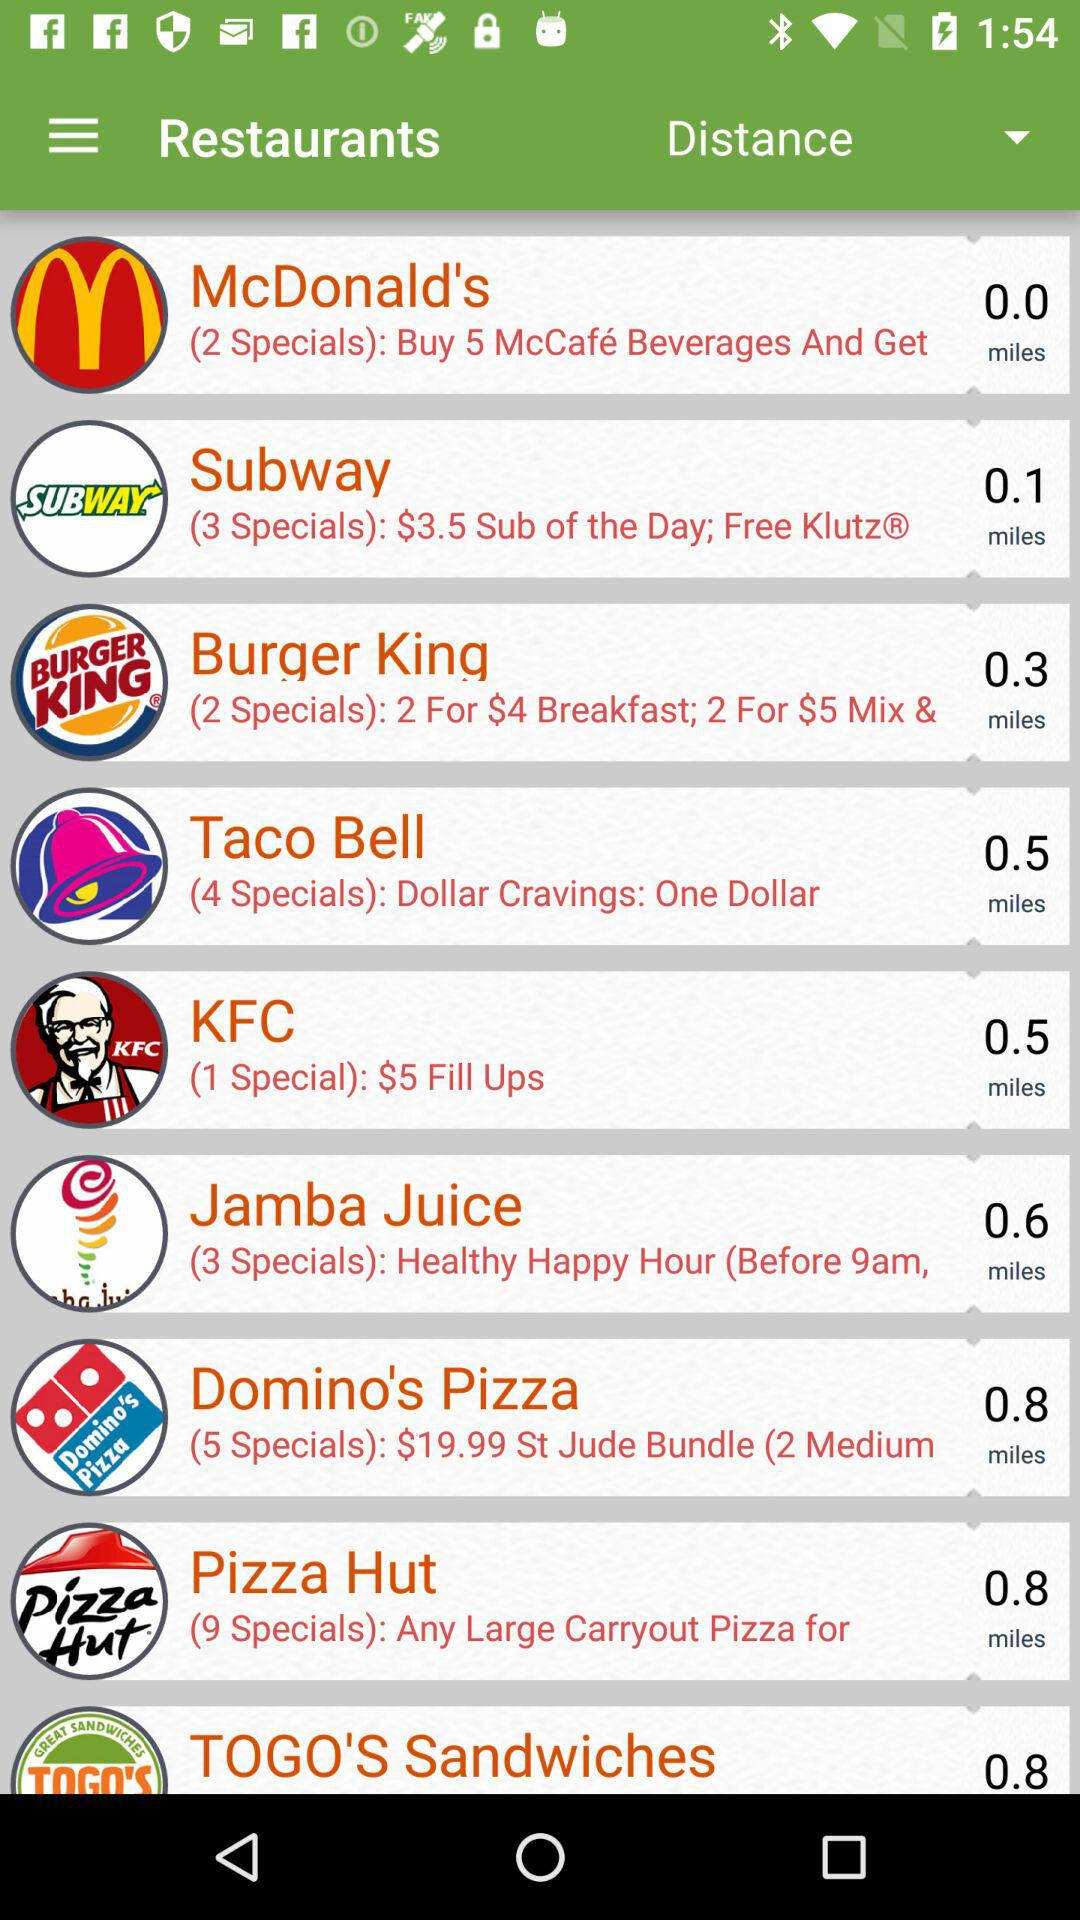Which restaurant has the lowest distance from the user?
Answer the question using a single word or phrase. McDonald's 